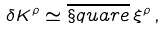<formula> <loc_0><loc_0><loc_500><loc_500>\delta K ^ { \rho } \simeq \overline { \S q u a r e } \, \xi ^ { \rho } \, ,</formula> 